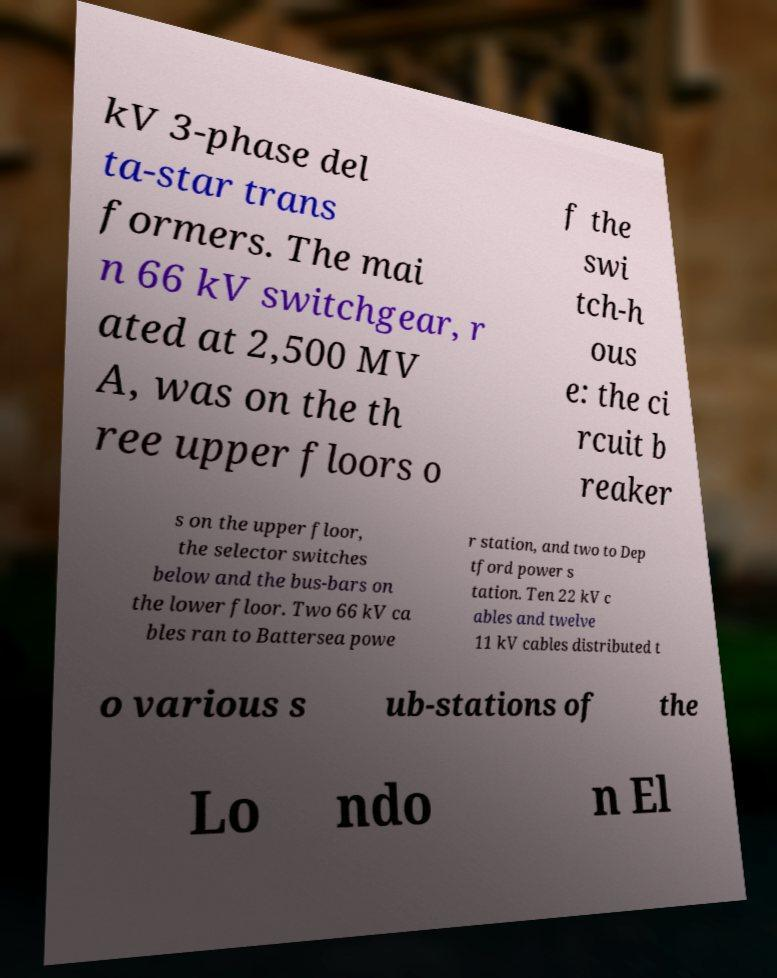I need the written content from this picture converted into text. Can you do that? kV 3-phase del ta-star trans formers. The mai n 66 kV switchgear, r ated at 2,500 MV A, was on the th ree upper floors o f the swi tch-h ous e: the ci rcuit b reaker s on the upper floor, the selector switches below and the bus-bars on the lower floor. Two 66 kV ca bles ran to Battersea powe r station, and two to Dep tford power s tation. Ten 22 kV c ables and twelve 11 kV cables distributed t o various s ub-stations of the Lo ndo n El 